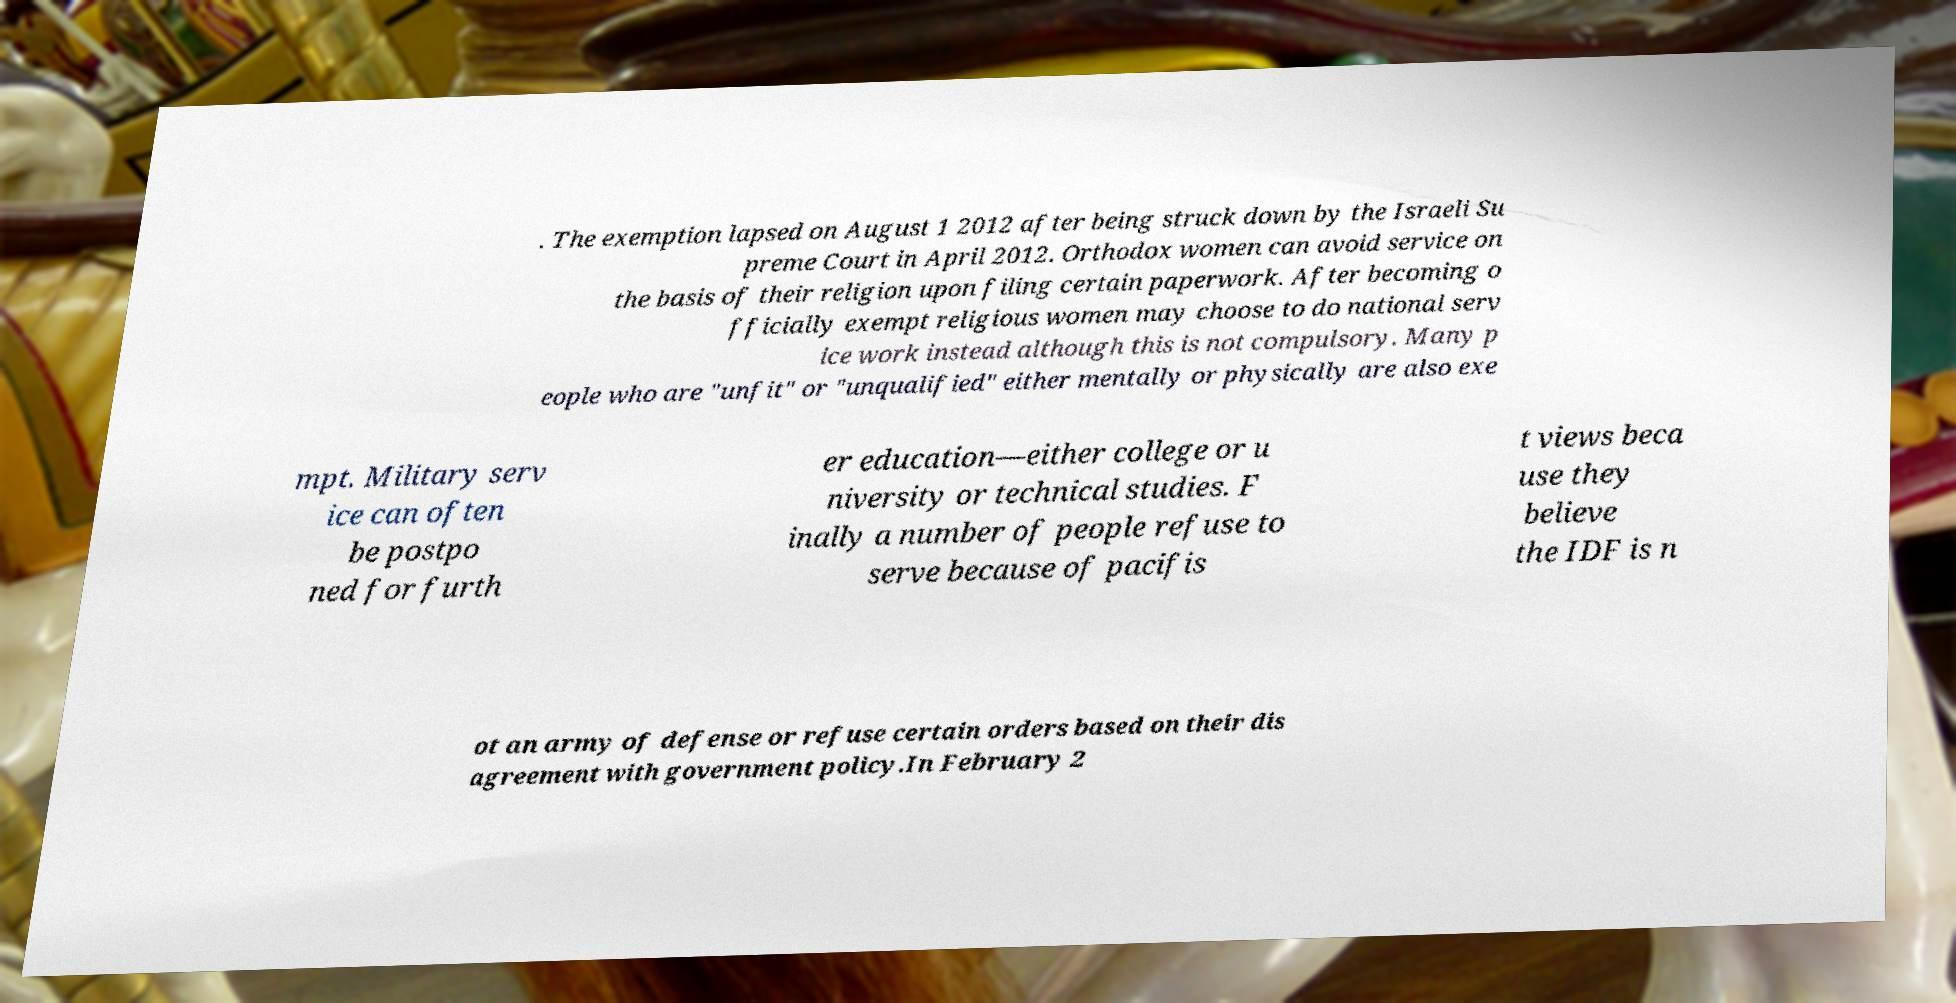Could you extract and type out the text from this image? . The exemption lapsed on August 1 2012 after being struck down by the Israeli Su preme Court in April 2012. Orthodox women can avoid service on the basis of their religion upon filing certain paperwork. After becoming o fficially exempt religious women may choose to do national serv ice work instead although this is not compulsory. Many p eople who are "unfit" or "unqualified" either mentally or physically are also exe mpt. Military serv ice can often be postpo ned for furth er education—either college or u niversity or technical studies. F inally a number of people refuse to serve because of pacifis t views beca use they believe the IDF is n ot an army of defense or refuse certain orders based on their dis agreement with government policy.In February 2 